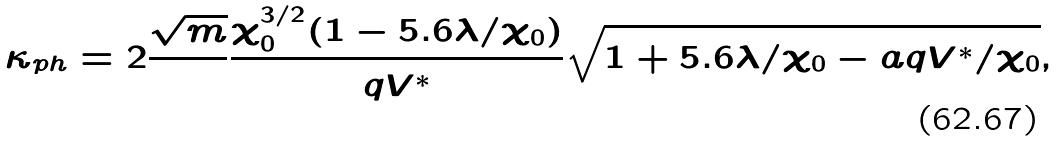Convert formula to latex. <formula><loc_0><loc_0><loc_500><loc_500>\kappa _ { p h } = 2 \frac { \sqrt { m } } { } \frac { \chi _ { 0 } ^ { 3 / 2 } ( 1 - 5 . 6 \lambda / \chi _ { 0 } ) } { q V ^ { \ast } } \sqrt { 1 + 5 . 6 \lambda / \chi _ { 0 } - a q V ^ { \ast } / \chi _ { 0 } } ,</formula> 